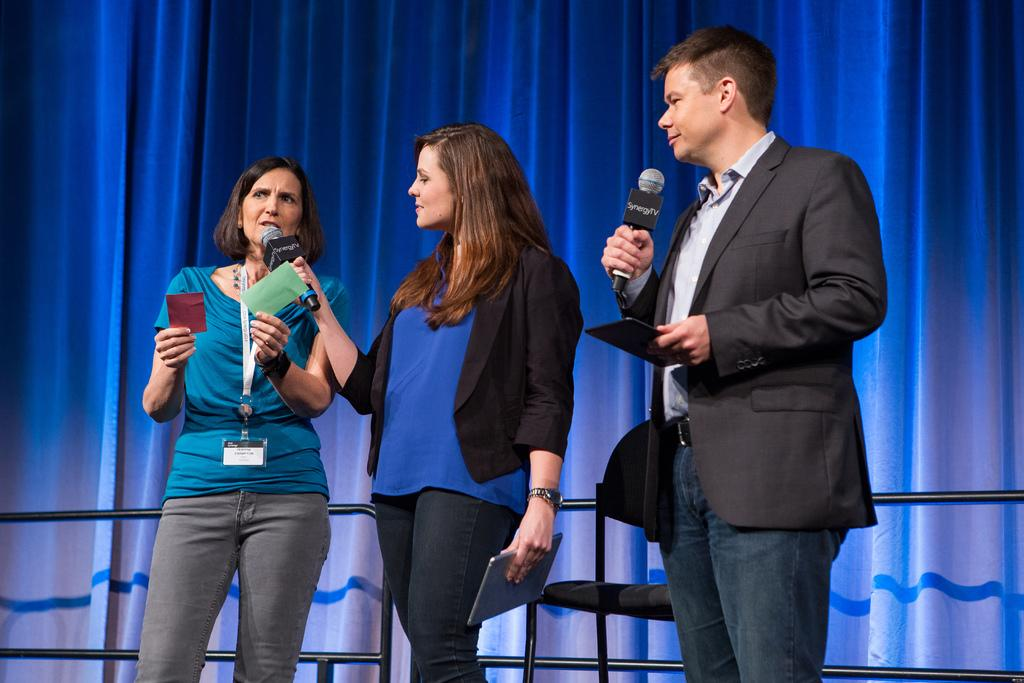What are the people in the image doing? The people in the image are holding objects. Can you describe any furniture in the image? Yes, there is a chair in the image. What type of barrier can be seen in the image? There is a fence in the image. What can be seen in the background of the image? There are curtains visible in the background of the image. How many cherries are on the fence in the image? There are no cherries present in the image; it only features people holding objects, a chair, a fence, and curtains in the background. 